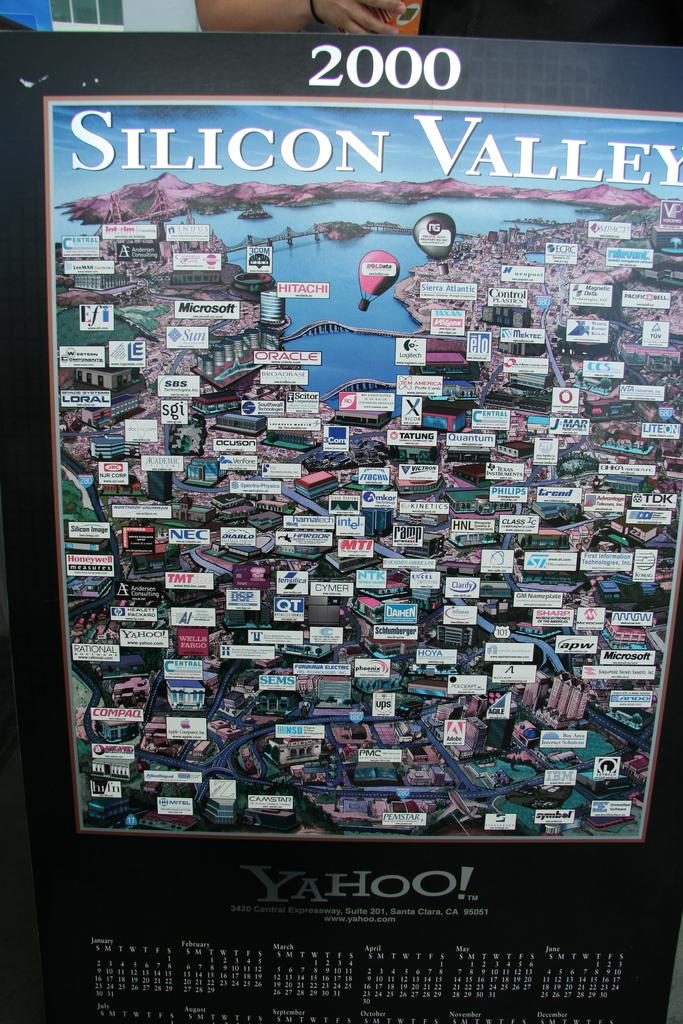<image>
Describe the image concisely. A laarge map of Silicon Valley with a calendar underneath advertising Yahoo! 